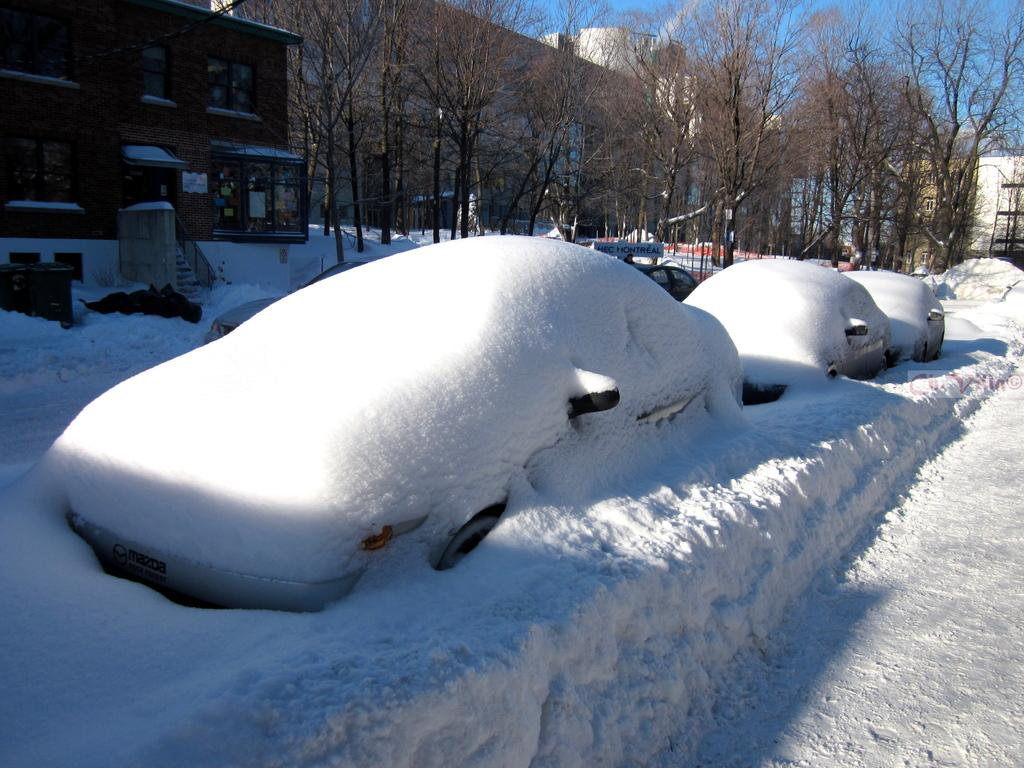What is covered with snow in the image? There are vehicles covered with snow in the image. What structures can be seen in the image? There are buildings in the image. What type of natural elements are present in the image? There are trees in the image. What is located near a building in the image? There are objects near a building in the image. What can be seen in the distance in the image? The sky is visible in the background of the image. Can you see a bubble floating near the trees in the image? There is no bubble present in the image. What type of border is visible around the buildings in the image? There is no border around the buildings in the image; they are surrounded by objects and trees. 